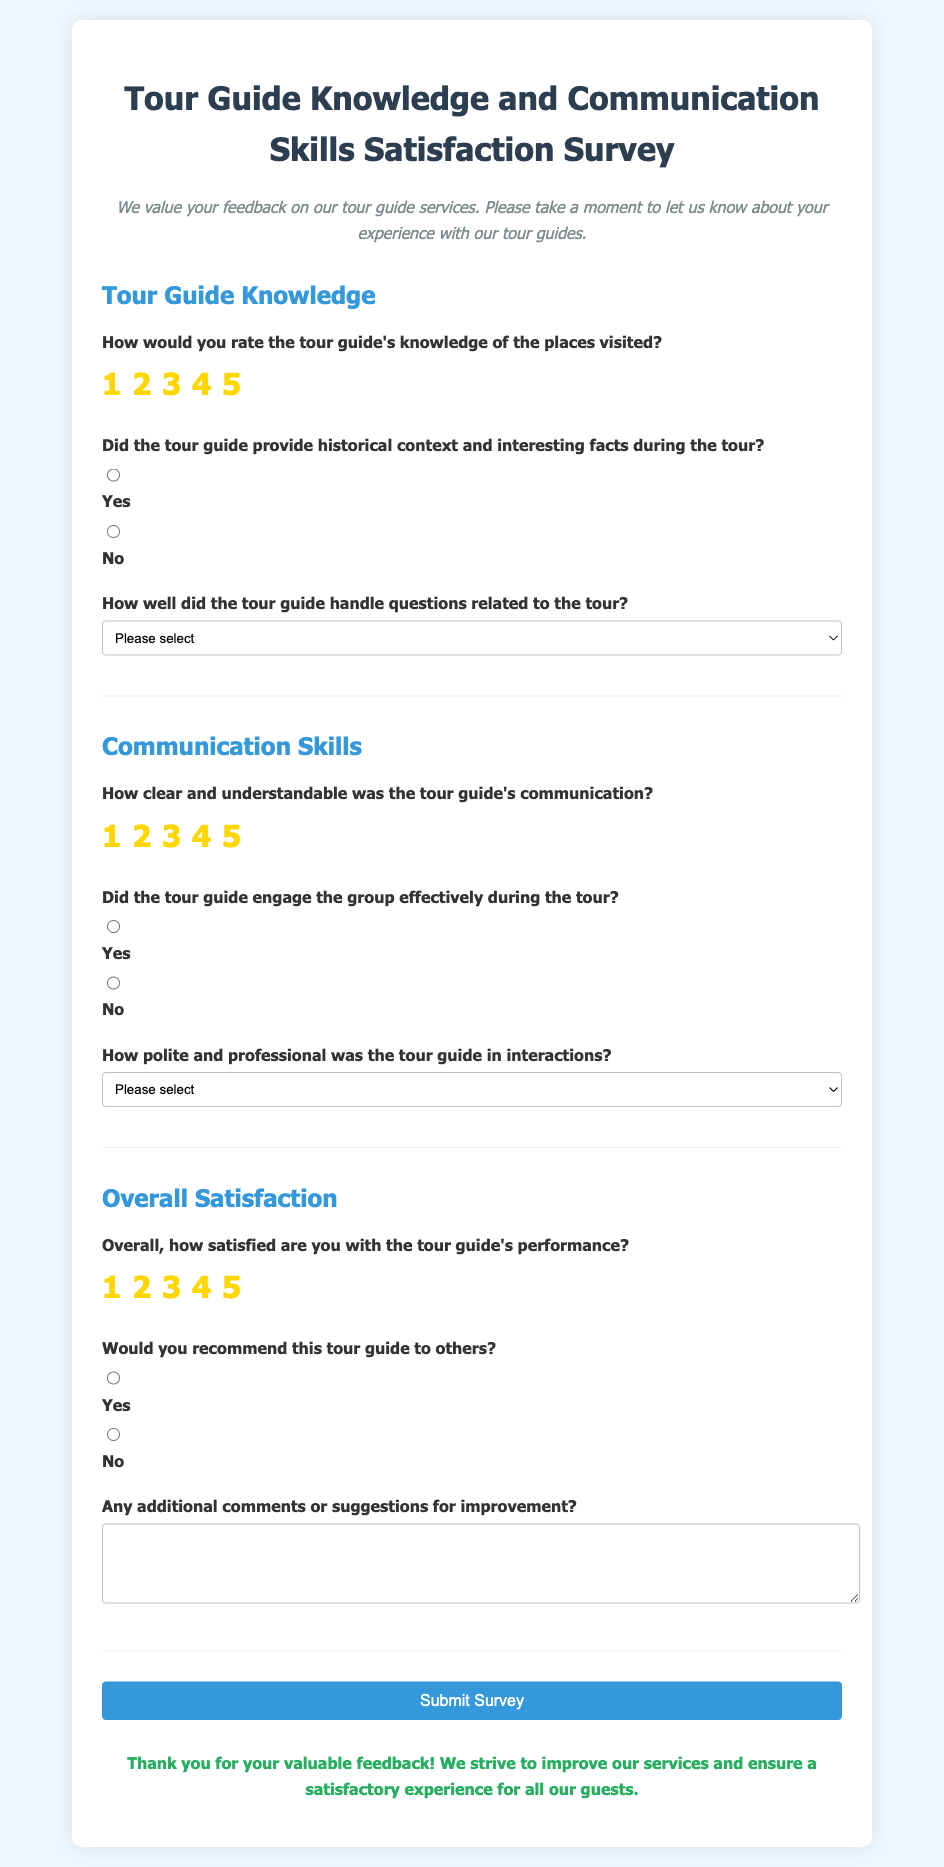How would you rate the tour guide's knowledge of the places visited? This question asks for the rating given by the respondent regarding the tour guide's knowledge based on a scale of 1 to 5, which is clearly represented as radio buttons in the rating section.
Answer: 1 to 5 Did the tour guide provide historical context and interesting facts during the tour? This is a yes/no question where respondents select one of the two options regarding the provision of historical context by the tour guide.
Answer: Yes or No How well did the tour guide handle questions related to the tour? This question requires selection from a dropdown menu that offers options for how well the tour guide handled questions, represented in a list format.
Answer: Very well, Satisfactorily, Poorly, or Not applicable How clear and understandable was the tour guide's communication? This question asks for a rating from 1 to 5 specifically focused on the clarity of communication, which is represented by radio buttons.
Answer: 1 to 5 Overall, how satisfied are you with the tour guide's performance? The respondent is required to provide an overall satisfaction rating using a scale from 1 to 5, represented in the document with radio buttons.
Answer: 1 to 5 Would you recommend this tour guide to others? This simple yes/no question allows respondents to indicate whether they would recommend the guide, demonstrated with two radio button options.
Answer: Yes or No What additional comments can be made for improvement? This question provides an open-ended response area for any suggestions or comments, allowing for a more qualitative response.
Answer: Open-ended response What color is the background of the survey container? This question focuses on the stylistic choice of the survey document, which is an attribute found under the CSS style section.
Answer: White What is the title of the survey? The title is prominently displayed at the top of the document and summarizes the purpose of the survey.
Answer: Tour Guide Knowledge and Communication Skills Satisfaction Survey How many sections are there in the survey? This question pertains to the structure of the document, which categorizes the survey into specific parts for easier navigation.
Answer: Three sections 